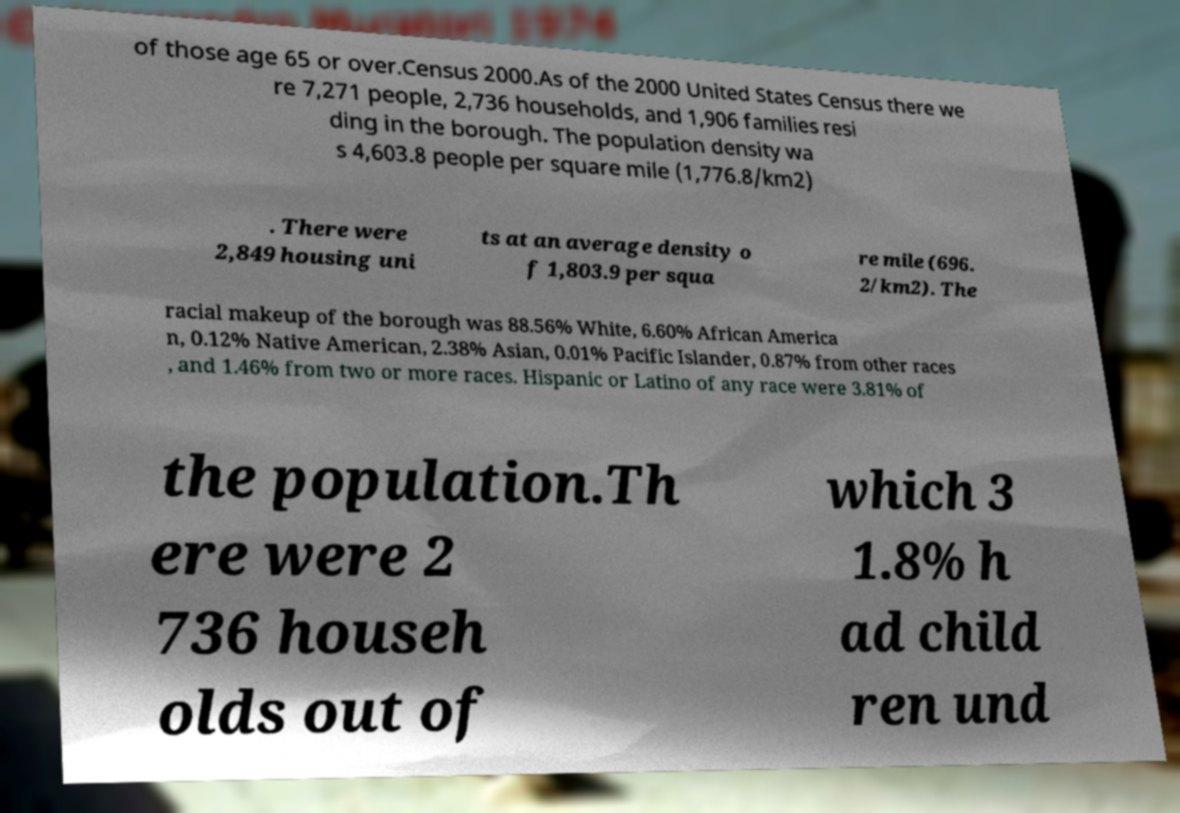Please identify and transcribe the text found in this image. of those age 65 or over.Census 2000.As of the 2000 United States Census there we re 7,271 people, 2,736 households, and 1,906 families resi ding in the borough. The population density wa s 4,603.8 people per square mile (1,776.8/km2) . There were 2,849 housing uni ts at an average density o f 1,803.9 per squa re mile (696. 2/km2). The racial makeup of the borough was 88.56% White, 6.60% African America n, 0.12% Native American, 2.38% Asian, 0.01% Pacific Islander, 0.87% from other races , and 1.46% from two or more races. Hispanic or Latino of any race were 3.81% of the population.Th ere were 2 736 househ olds out of which 3 1.8% h ad child ren und 